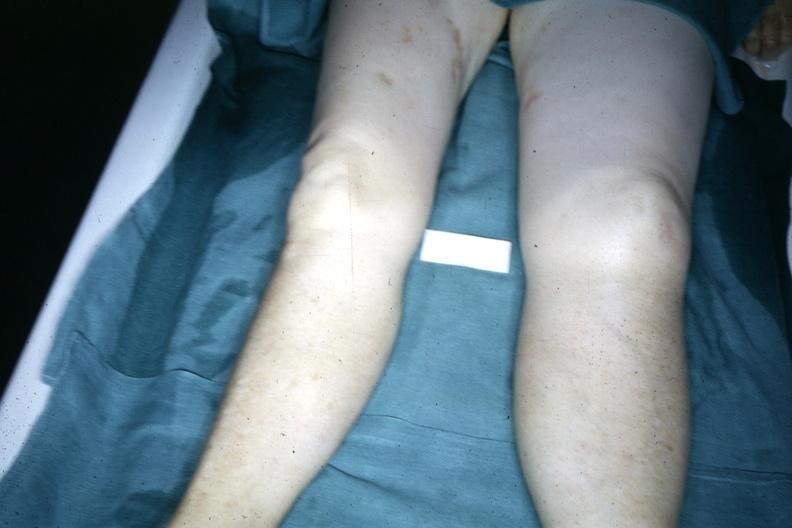what are present?
Answer the question using a single word or phrase. Extremities 